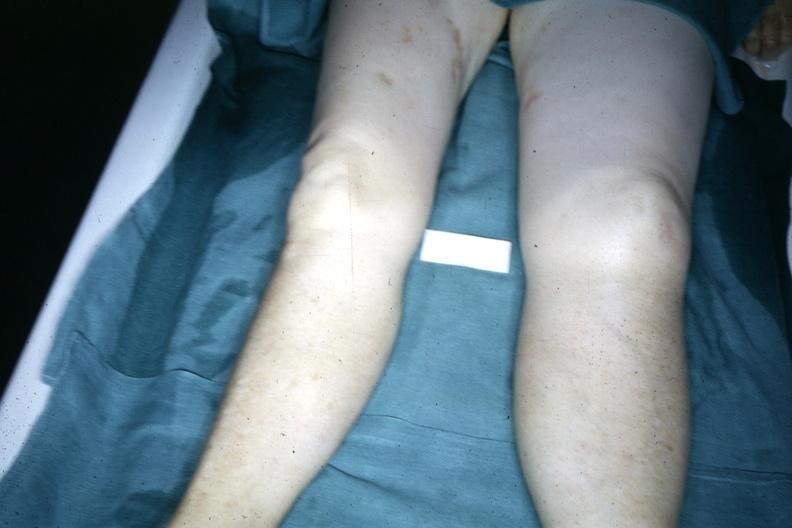what are present?
Answer the question using a single word or phrase. Extremities 